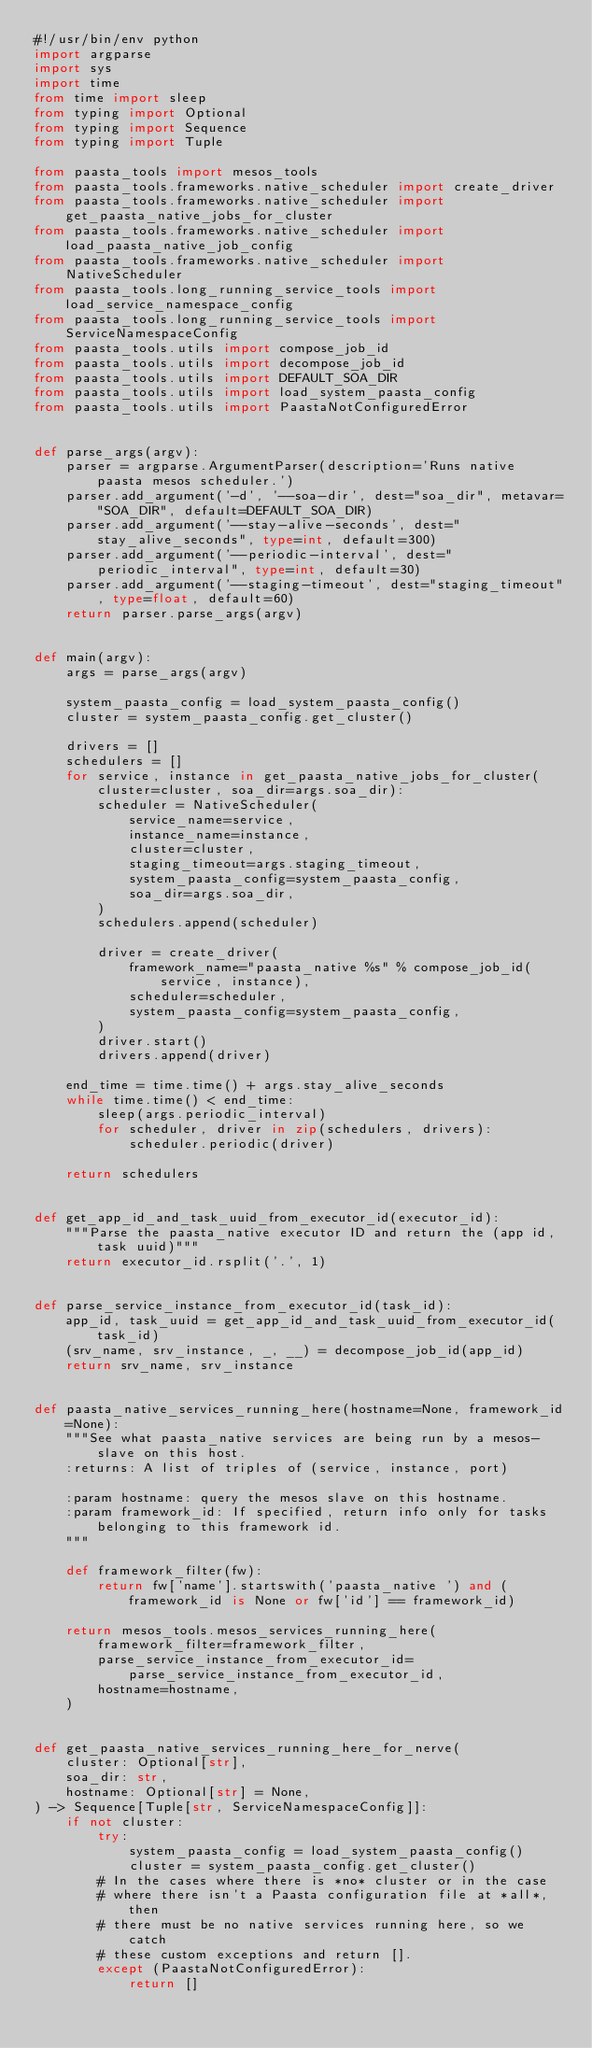<code> <loc_0><loc_0><loc_500><loc_500><_Python_>#!/usr/bin/env python
import argparse
import sys
import time
from time import sleep
from typing import Optional
from typing import Sequence
from typing import Tuple

from paasta_tools import mesos_tools
from paasta_tools.frameworks.native_scheduler import create_driver
from paasta_tools.frameworks.native_scheduler import get_paasta_native_jobs_for_cluster
from paasta_tools.frameworks.native_scheduler import load_paasta_native_job_config
from paasta_tools.frameworks.native_scheduler import NativeScheduler
from paasta_tools.long_running_service_tools import load_service_namespace_config
from paasta_tools.long_running_service_tools import ServiceNamespaceConfig
from paasta_tools.utils import compose_job_id
from paasta_tools.utils import decompose_job_id
from paasta_tools.utils import DEFAULT_SOA_DIR
from paasta_tools.utils import load_system_paasta_config
from paasta_tools.utils import PaastaNotConfiguredError


def parse_args(argv):
    parser = argparse.ArgumentParser(description='Runs native paasta mesos scheduler.')
    parser.add_argument('-d', '--soa-dir', dest="soa_dir", metavar="SOA_DIR", default=DEFAULT_SOA_DIR)
    parser.add_argument('--stay-alive-seconds', dest="stay_alive_seconds", type=int, default=300)
    parser.add_argument('--periodic-interval', dest="periodic_interval", type=int, default=30)
    parser.add_argument('--staging-timeout', dest="staging_timeout", type=float, default=60)
    return parser.parse_args(argv)


def main(argv):
    args = parse_args(argv)

    system_paasta_config = load_system_paasta_config()
    cluster = system_paasta_config.get_cluster()

    drivers = []
    schedulers = []
    for service, instance in get_paasta_native_jobs_for_cluster(cluster=cluster, soa_dir=args.soa_dir):
        scheduler = NativeScheduler(
            service_name=service,
            instance_name=instance,
            cluster=cluster,
            staging_timeout=args.staging_timeout,
            system_paasta_config=system_paasta_config,
            soa_dir=args.soa_dir,
        )
        schedulers.append(scheduler)

        driver = create_driver(
            framework_name="paasta_native %s" % compose_job_id(service, instance),
            scheduler=scheduler,
            system_paasta_config=system_paasta_config,
        )
        driver.start()
        drivers.append(driver)

    end_time = time.time() + args.stay_alive_seconds
    while time.time() < end_time:
        sleep(args.periodic_interval)
        for scheduler, driver in zip(schedulers, drivers):
            scheduler.periodic(driver)

    return schedulers


def get_app_id_and_task_uuid_from_executor_id(executor_id):
    """Parse the paasta_native executor ID and return the (app id, task uuid)"""
    return executor_id.rsplit('.', 1)


def parse_service_instance_from_executor_id(task_id):
    app_id, task_uuid = get_app_id_and_task_uuid_from_executor_id(task_id)
    (srv_name, srv_instance, _, __) = decompose_job_id(app_id)
    return srv_name, srv_instance


def paasta_native_services_running_here(hostname=None, framework_id=None):
    """See what paasta_native services are being run by a mesos-slave on this host.
    :returns: A list of triples of (service, instance, port)

    :param hostname: query the mesos slave on this hostname.
    :param framework_id: If specified, return info only for tasks belonging to this framework id.
    """

    def framework_filter(fw):
        return fw['name'].startswith('paasta_native ') and (framework_id is None or fw['id'] == framework_id)

    return mesos_tools.mesos_services_running_here(
        framework_filter=framework_filter,
        parse_service_instance_from_executor_id=parse_service_instance_from_executor_id,
        hostname=hostname,
    )


def get_paasta_native_services_running_here_for_nerve(
    cluster: Optional[str],
    soa_dir: str,
    hostname: Optional[str] = None,
) -> Sequence[Tuple[str, ServiceNamespaceConfig]]:
    if not cluster:
        try:
            system_paasta_config = load_system_paasta_config()
            cluster = system_paasta_config.get_cluster()
        # In the cases where there is *no* cluster or in the case
        # where there isn't a Paasta configuration file at *all*, then
        # there must be no native services running here, so we catch
        # these custom exceptions and return [].
        except (PaastaNotConfiguredError):
            return []</code> 